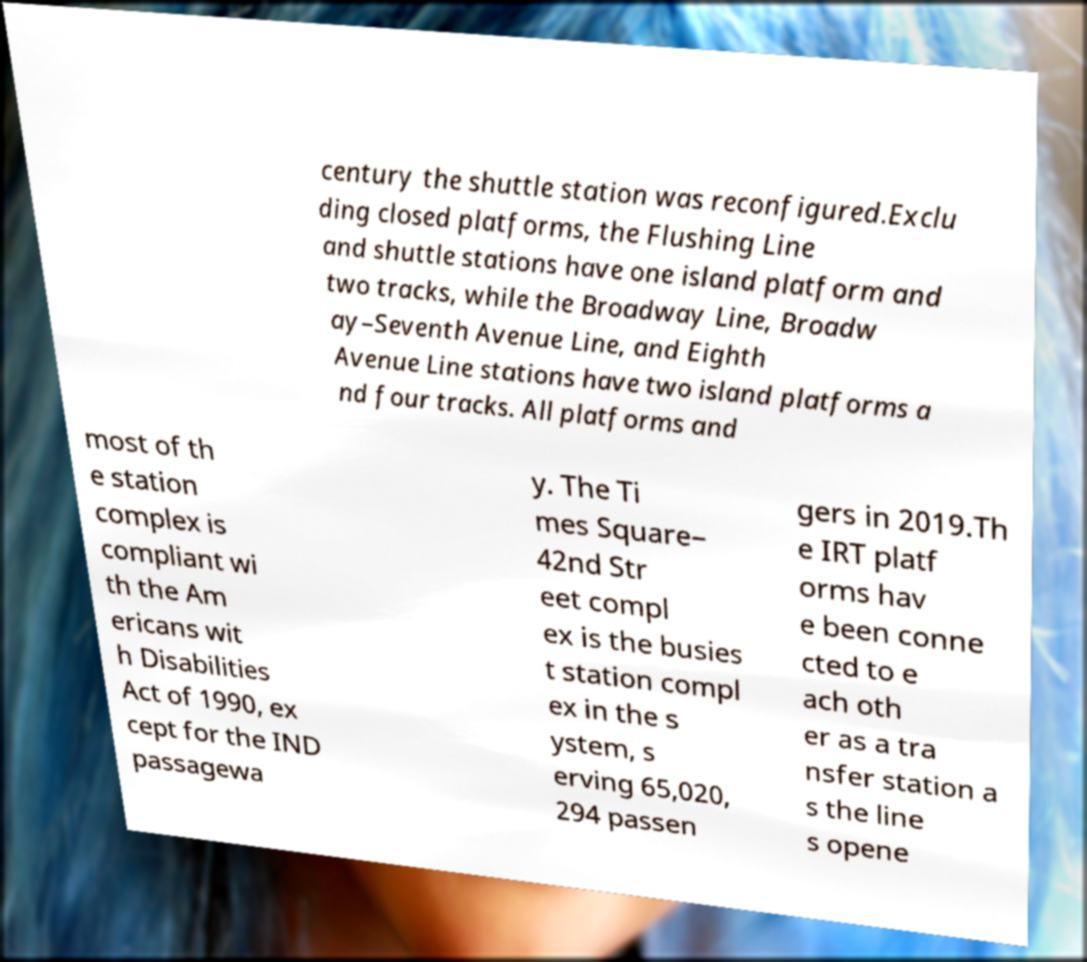What messages or text are displayed in this image? I need them in a readable, typed format. century the shuttle station was reconfigured.Exclu ding closed platforms, the Flushing Line and shuttle stations have one island platform and two tracks, while the Broadway Line, Broadw ay–Seventh Avenue Line, and Eighth Avenue Line stations have two island platforms a nd four tracks. All platforms and most of th e station complex is compliant wi th the Am ericans wit h Disabilities Act of 1990, ex cept for the IND passagewa y. The Ti mes Square– 42nd Str eet compl ex is the busies t station compl ex in the s ystem, s erving 65,020, 294 passen gers in 2019.Th e IRT platf orms hav e been conne cted to e ach oth er as a tra nsfer station a s the line s opene 